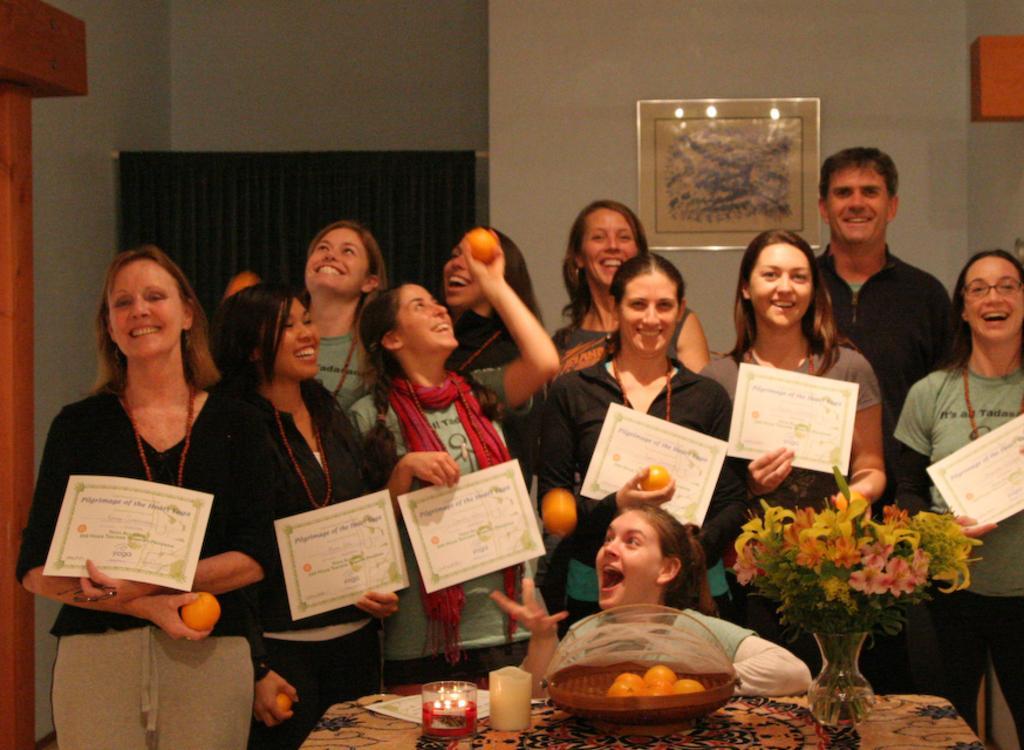Describe this image in one or two sentences. In this image we can see a group of people and they are holding some objects in their hands. There is a photo on the wall. We can see the light reflections on the photo. There are many objects on the table. There is a curtain at the left side of the image. 